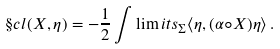<formula> <loc_0><loc_0><loc_500><loc_500>\S c l ( X , \eta ) = - \frac { 1 } { 2 } \int \lim i t s _ { \Sigma } \langle \eta , ( \alpha \circ X ) \eta \rangle \, .</formula> 